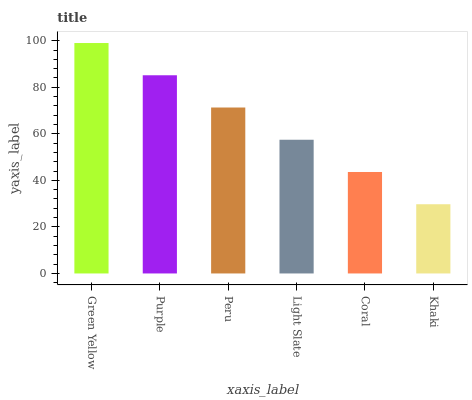Is Purple the minimum?
Answer yes or no. No. Is Purple the maximum?
Answer yes or no. No. Is Green Yellow greater than Purple?
Answer yes or no. Yes. Is Purple less than Green Yellow?
Answer yes or no. Yes. Is Purple greater than Green Yellow?
Answer yes or no. No. Is Green Yellow less than Purple?
Answer yes or no. No. Is Peru the high median?
Answer yes or no. Yes. Is Light Slate the low median?
Answer yes or no. Yes. Is Purple the high median?
Answer yes or no. No. Is Peru the low median?
Answer yes or no. No. 